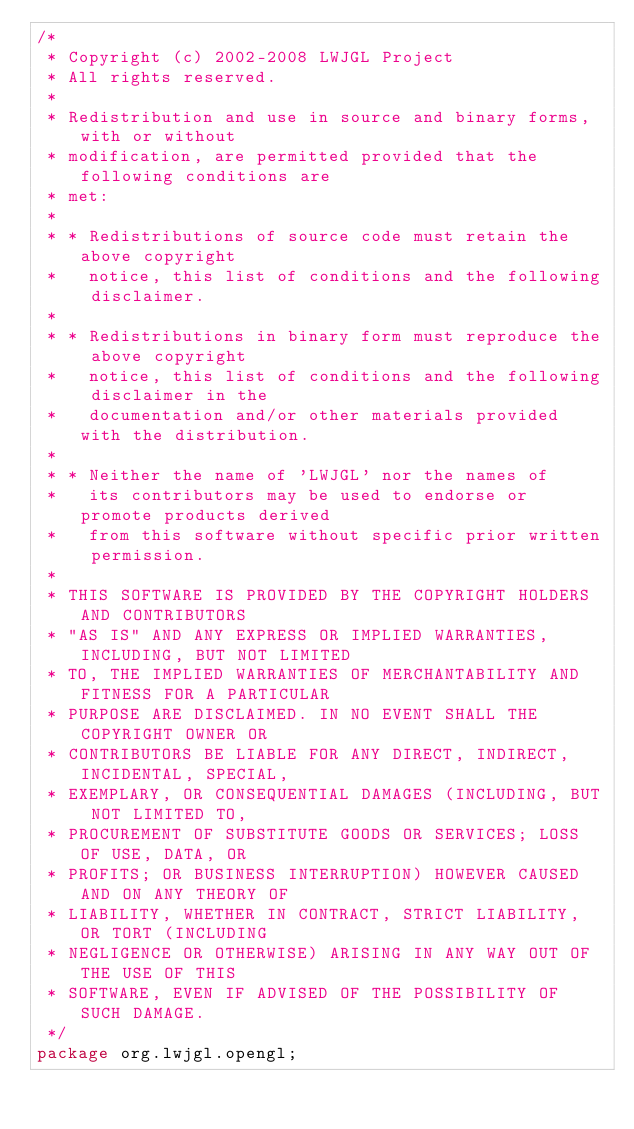Convert code to text. <code><loc_0><loc_0><loc_500><loc_500><_Java_>/*
 * Copyright (c) 2002-2008 LWJGL Project
 * All rights reserved.
 *
 * Redistribution and use in source and binary forms, with or without
 * modification, are permitted provided that the following conditions are
 * met:
 *
 * * Redistributions of source code must retain the above copyright
 *   notice, this list of conditions and the following disclaimer.
 *
 * * Redistributions in binary form must reproduce the above copyright
 *   notice, this list of conditions and the following disclaimer in the
 *   documentation and/or other materials provided with the distribution.
 *
 * * Neither the name of 'LWJGL' nor the names of
 *   its contributors may be used to endorse or promote products derived
 *   from this software without specific prior written permission.
 *
 * THIS SOFTWARE IS PROVIDED BY THE COPYRIGHT HOLDERS AND CONTRIBUTORS
 * "AS IS" AND ANY EXPRESS OR IMPLIED WARRANTIES, INCLUDING, BUT NOT LIMITED
 * TO, THE IMPLIED WARRANTIES OF MERCHANTABILITY AND FITNESS FOR A PARTICULAR
 * PURPOSE ARE DISCLAIMED. IN NO EVENT SHALL THE COPYRIGHT OWNER OR
 * CONTRIBUTORS BE LIABLE FOR ANY DIRECT, INDIRECT, INCIDENTAL, SPECIAL,
 * EXEMPLARY, OR CONSEQUENTIAL DAMAGES (INCLUDING, BUT NOT LIMITED TO,
 * PROCUREMENT OF SUBSTITUTE GOODS OR SERVICES; LOSS OF USE, DATA, OR
 * PROFITS; OR BUSINESS INTERRUPTION) HOWEVER CAUSED AND ON ANY THEORY OF
 * LIABILITY, WHETHER IN CONTRACT, STRICT LIABILITY, OR TORT (INCLUDING
 * NEGLIGENCE OR OTHERWISE) ARISING IN ANY WAY OUT OF THE USE OF THIS
 * SOFTWARE, EVEN IF ADVISED OF THE POSSIBILITY OF SUCH DAMAGE.
 */
package org.lwjgl.opengl;
</code> 